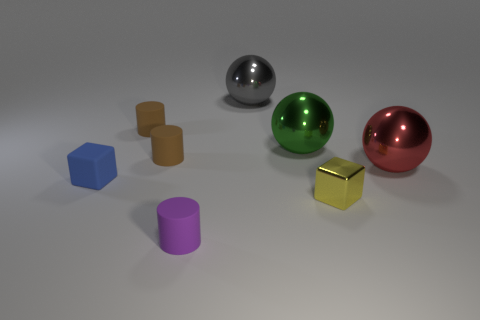Does the small blue block have the same material as the cylinder that is in front of the big red ball? yes 